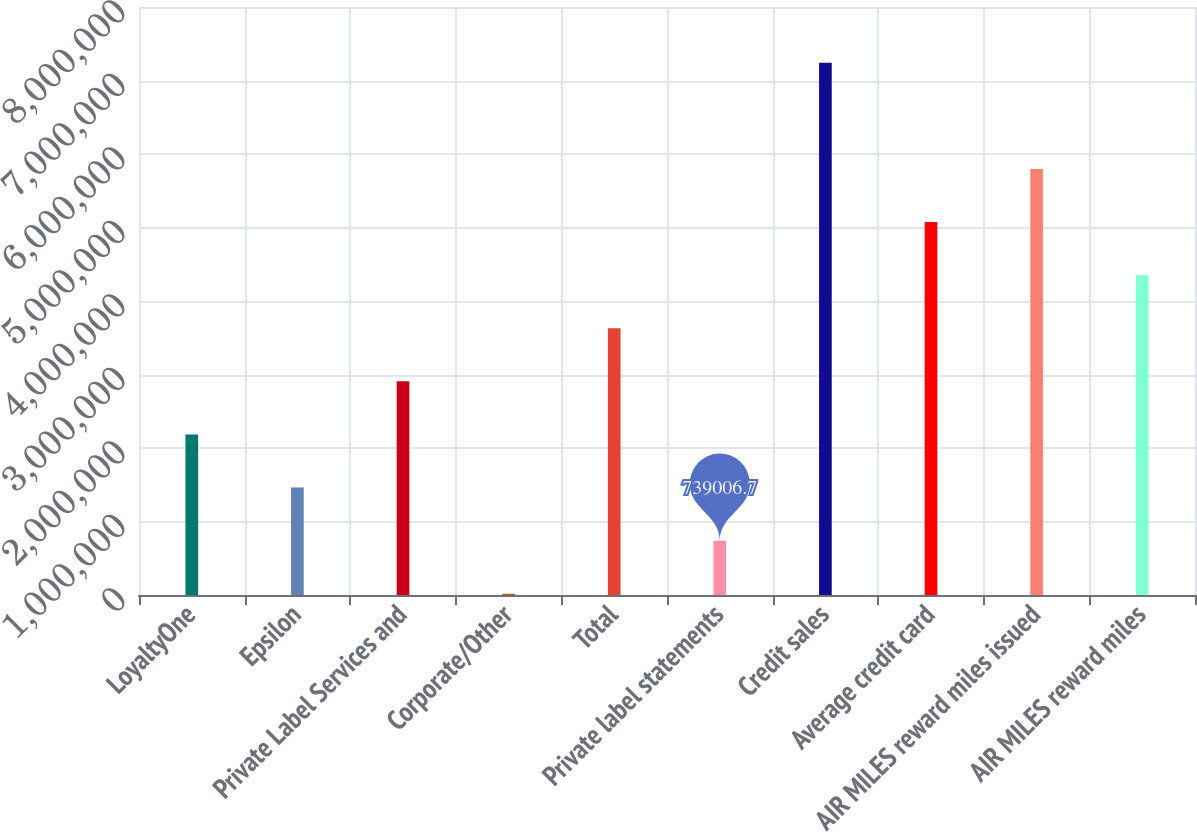Convert chart. <chart><loc_0><loc_0><loc_500><loc_500><bar_chart><fcel>LoyaltyOne<fcel>Epsilon<fcel>Private Label Services and<fcel>Corporate/Other<fcel>Total<fcel>Private label statements<fcel>Credit sales<fcel>Average credit card<fcel>AIR MILES reward miles issued<fcel>AIR MILES reward miles<nl><fcel>2.18421e+06<fcel>1.46161e+06<fcel>2.90681e+06<fcel>16405<fcel>3.62941e+06<fcel>739007<fcel>7.24242e+06<fcel>5.07462e+06<fcel>5.79722e+06<fcel>4.35202e+06<nl></chart> 